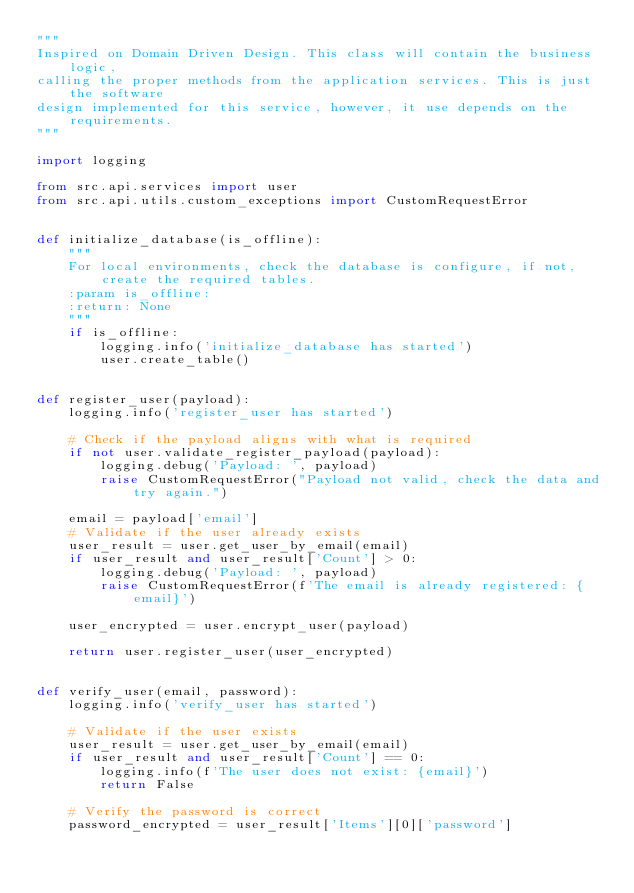<code> <loc_0><loc_0><loc_500><loc_500><_Python_>"""
Inspired on Domain Driven Design. This class will contain the business logic,
calling the proper methods from the application services. This is just the software
design implemented for this service, however, it use depends on the requirements.
"""

import logging

from src.api.services import user
from src.api.utils.custom_exceptions import CustomRequestError


def initialize_database(is_offline):
    """
    For local environments, check the database is configure, if not, create the required tables.
    :param is_offline:
    :return: None
    """
    if is_offline:
        logging.info('initialize_database has started')
        user.create_table()


def register_user(payload):
    logging.info('register_user has started')

    # Check if the payload aligns with what is required
    if not user.validate_register_payload(payload):
        logging.debug('Payload: ', payload)
        raise CustomRequestError("Payload not valid, check the data and try again.")

    email = payload['email']
    # Validate if the user already exists
    user_result = user.get_user_by_email(email)
    if user_result and user_result['Count'] > 0:
        logging.debug('Payload: ', payload)
        raise CustomRequestError(f'The email is already registered: {email}')

    user_encrypted = user.encrypt_user(payload)

    return user.register_user(user_encrypted)


def verify_user(email, password):
    logging.info('verify_user has started')

    # Validate if the user exists
    user_result = user.get_user_by_email(email)
    if user_result and user_result['Count'] == 0:
        logging.info(f'The user does not exist: {email}')
        return False

    # Verify the password is correct
    password_encrypted = user_result['Items'][0]['password']
</code> 